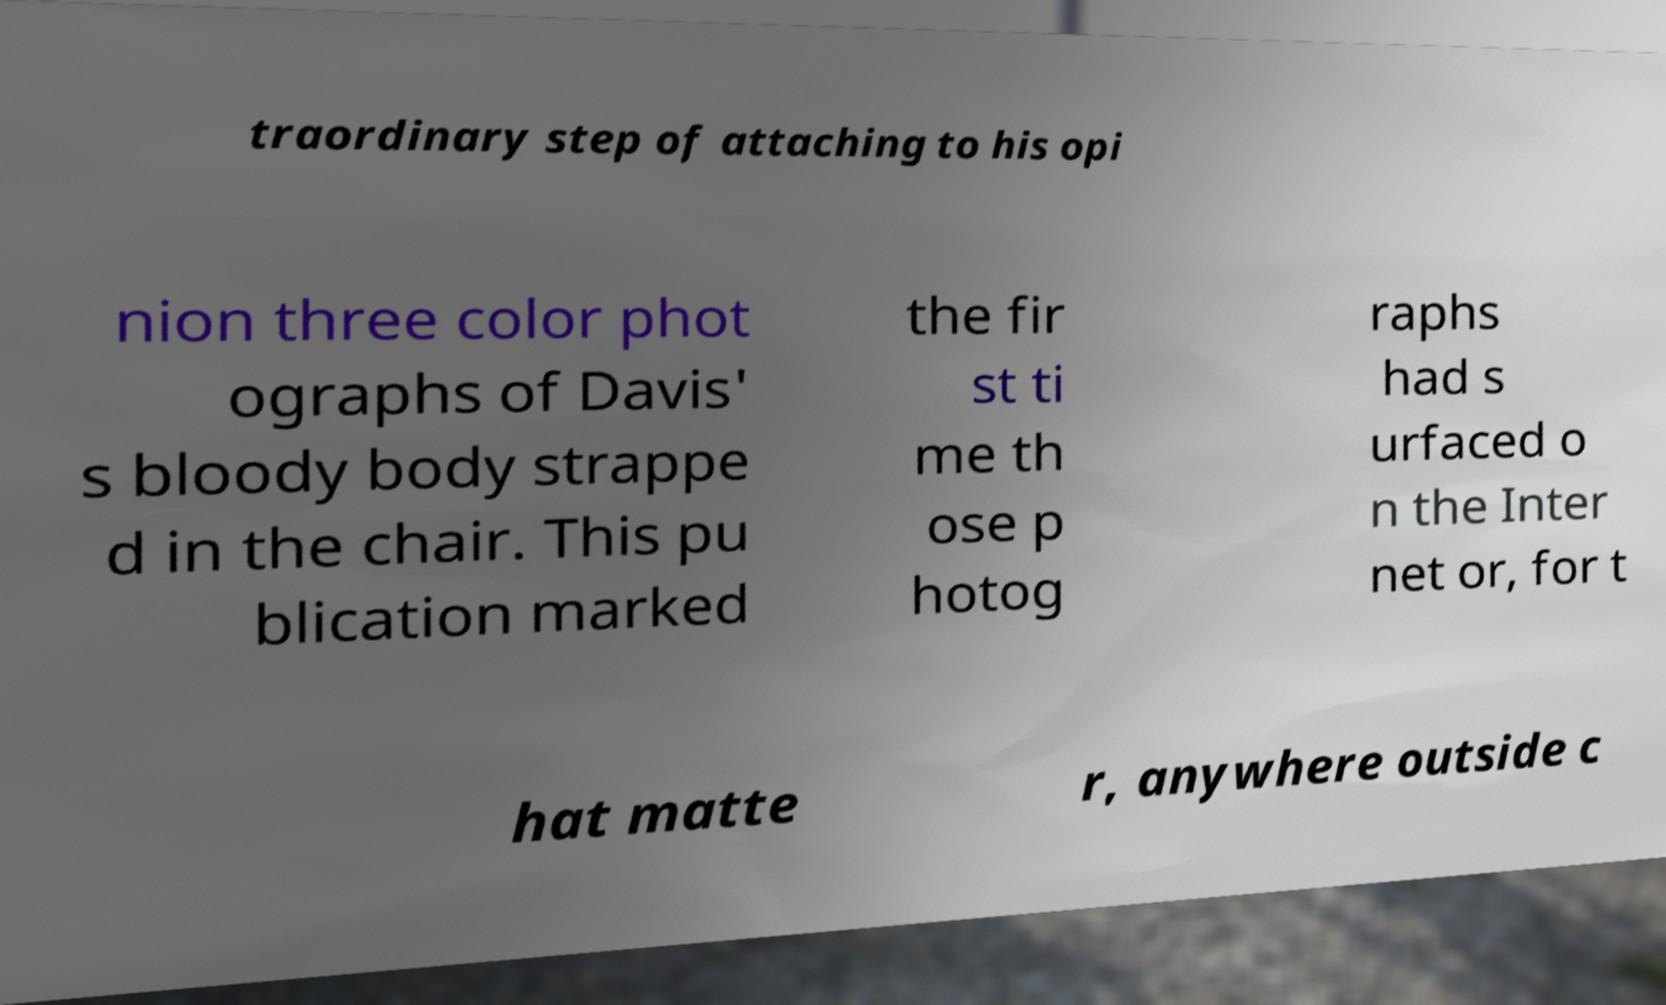Could you extract and type out the text from this image? traordinary step of attaching to his opi nion three color phot ographs of Davis' s bloody body strappe d in the chair. This pu blication marked the fir st ti me th ose p hotog raphs had s urfaced o n the Inter net or, for t hat matte r, anywhere outside c 